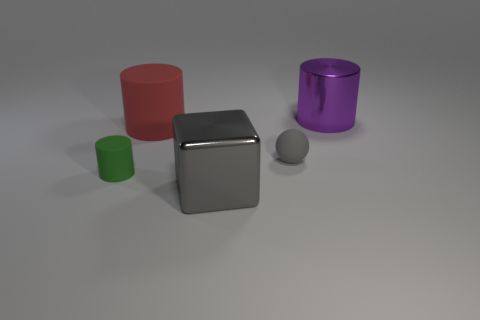What number of tiny rubber objects are right of the big cube and in front of the matte sphere?
Your answer should be very brief. 0. What is the material of the gray thing behind the tiny cylinder?
Provide a succinct answer. Rubber. The gray block that is the same material as the big purple thing is what size?
Ensure brevity in your answer.  Large. Are there any large red rubber cylinders behind the large matte object?
Provide a short and direct response. No. There is a shiny object that is the same shape as the red rubber object; what size is it?
Provide a short and direct response. Large. There is a big block; does it have the same color as the big object on the left side of the gray metal object?
Your answer should be very brief. No. Is the rubber sphere the same color as the big cube?
Ensure brevity in your answer.  Yes. Is the number of small yellow metal objects less than the number of balls?
Keep it short and to the point. Yes. What number of other objects are the same color as the big shiny cube?
Offer a terse response. 1. How many tiny red things are there?
Provide a succinct answer. 0. 